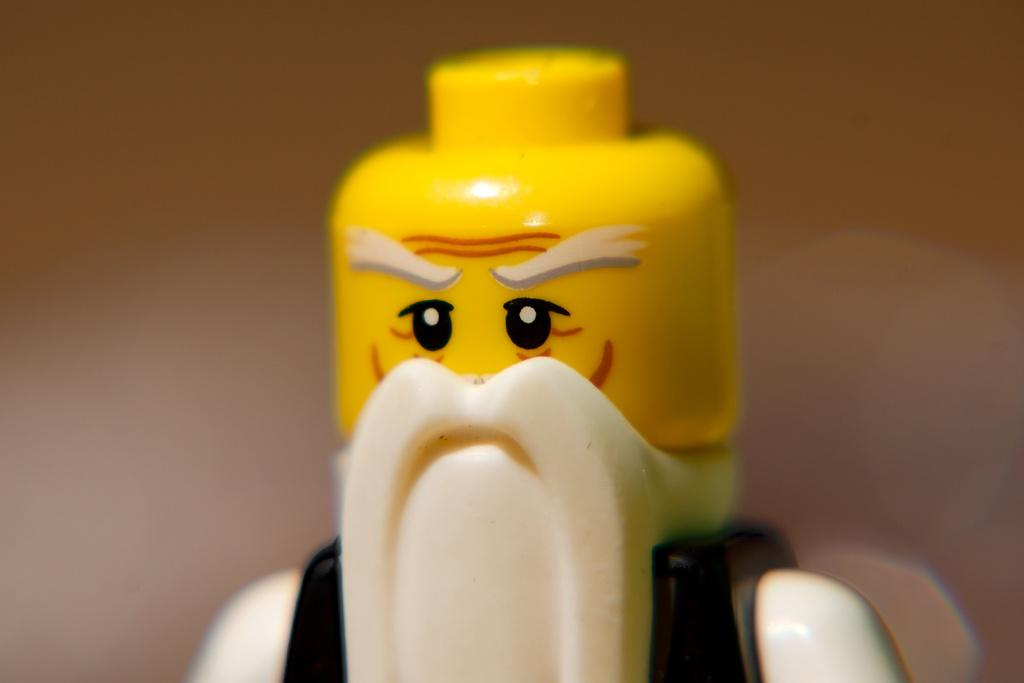What is the main subject in the image? There is a Lego man in the image. Can you describe the background of the image? The background of the image is blurred. What type of agreement is being discussed by the Lego man in the image? There is no indication in the image that the Lego man is discussing any type of agreement. 